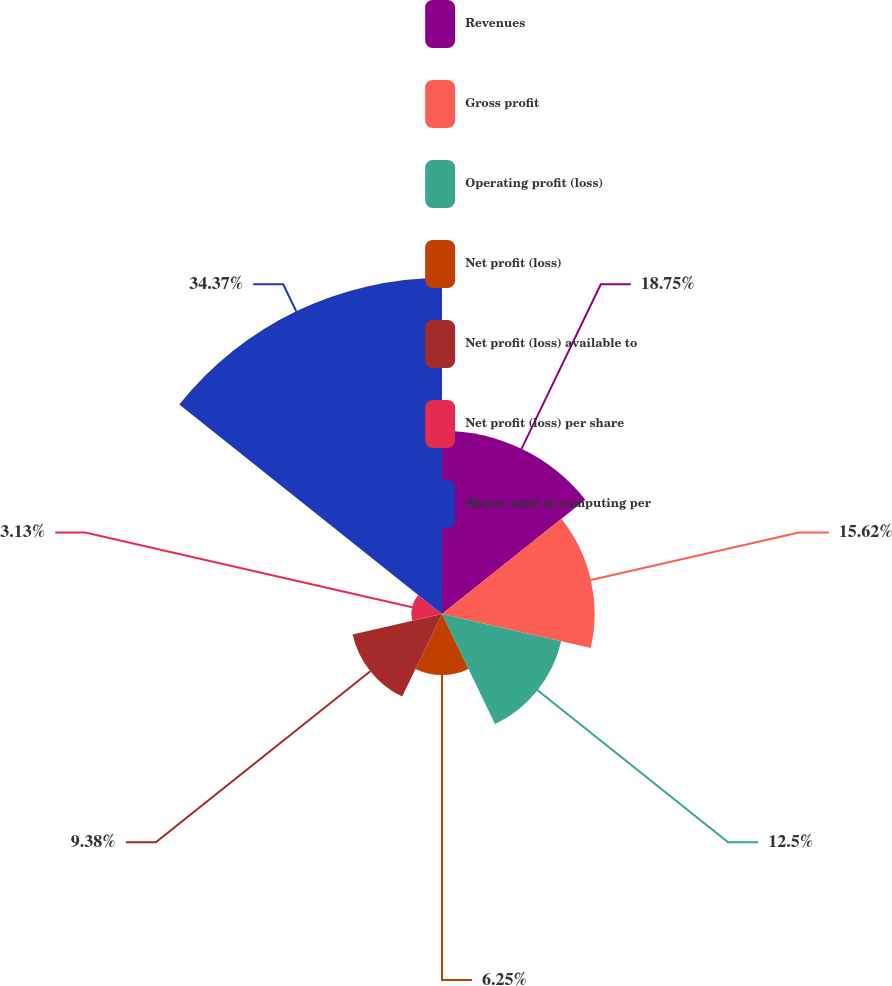Convert chart to OTSL. <chart><loc_0><loc_0><loc_500><loc_500><pie_chart><fcel>Revenues<fcel>Gross profit<fcel>Operating profit (loss)<fcel>Net profit (loss)<fcel>Net profit (loss) available to<fcel>Net profit (loss) per share<fcel>Shares used in computing per<nl><fcel>18.75%<fcel>15.62%<fcel>12.5%<fcel>6.25%<fcel>9.38%<fcel>3.13%<fcel>34.37%<nl></chart> 